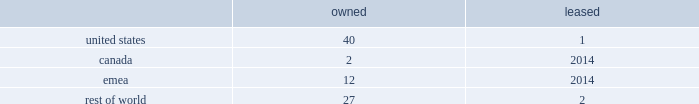Volatility of capital markets or macroeconomic factors could adversely affect our business .
Changes in financial and capital markets , including market disruptions , limited liquidity , uncertainty regarding brexit , and interest rate volatility , including as a result of the use or discontinued use of certain benchmark rates such as libor , may increase the cost of financing as well as the risks of refinancing maturing debt .
In addition , our borrowing costs can be affected by short and long-term ratings assigned by rating organizations .
A decrease in these ratings could limit our access to capital markets and increase our borrowing costs , which could materially and adversely affect our financial condition and operating results .
Some of our customers and counterparties are highly leveraged .
Consolidations in some of the industries in which our customers operate have created larger customers , some of which are highly leveraged and facing increased competition and continued credit market volatility .
These factors have caused some customers to be less profitable , increasing our exposure to credit risk .
A significant adverse change in the financial and/or credit position of a customer or counterparty could require us to assume greater credit risk relating to that customer or counterparty and could limit our ability to collect receivables .
This could have an adverse impact on our financial condition and liquidity .
Item 1b .
Unresolved staff comments .
Item 2 .
Properties .
Our corporate co-headquarters are located in pittsburgh , pennsylvania and chicago , illinois .
Our co-headquarters are leased and house certain executive offices , our u.s .
Business units , and our administrative , finance , legal , and human resource functions .
We maintain additional owned and leased offices throughout the regions in which we operate .
We manufacture our products in our network of manufacturing and processing facilities located throughout the world .
As of december 29 , 2018 , we operated 84 manufacturing and processing facilities .
We own 81 and lease three of these facilities .
Our manufacturing and processing facilities count by segment as of december 29 , 2018 was: .
We maintain all of our manufacturing and processing facilities in good condition and believe they are suitable and are adequate for our present needs .
We also enter into co-manufacturing arrangements with third parties if we determine it is advantageous to outsource the production of any of our products .
In the fourth quarter of 2018 , we announced our plans to divest certain assets and operations , predominantly in canada and india , including one owned manufacturing facility in canada and one owned and one leased facility in india .
See note 5 , acquisitions and divestitures , in item 8 , financial statements and supplementary data , for additional information on these transactions .
Item 3 .
Legal proceedings .
See note 18 , commitments and contingencies , in item 8 , financial statements and supplementary data .
Item 4 .
Mine safety disclosures .
Not applicable .
Part ii item 5 .
Market for registrant's common equity , related stockholder matters and issuer purchases of equity securities .
Our common stock is listed on nasdaq under the ticker symbol 201ckhc 201d .
At june 5 , 2019 , there were approximately 49000 holders of record of our common stock .
See equity and dividends in item 7 , management 2019s discussion and analysis of financial condition and results of operations , for a discussion of cash dividends declared on our common stock. .
What percent of owned facilities are in the us? 
Computations: (40 / 81)
Answer: 0.49383. 